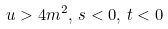Convert formula to latex. <formula><loc_0><loc_0><loc_500><loc_500>u > 4 m ^ { 2 } , \, s < 0 , \, t < 0</formula> 